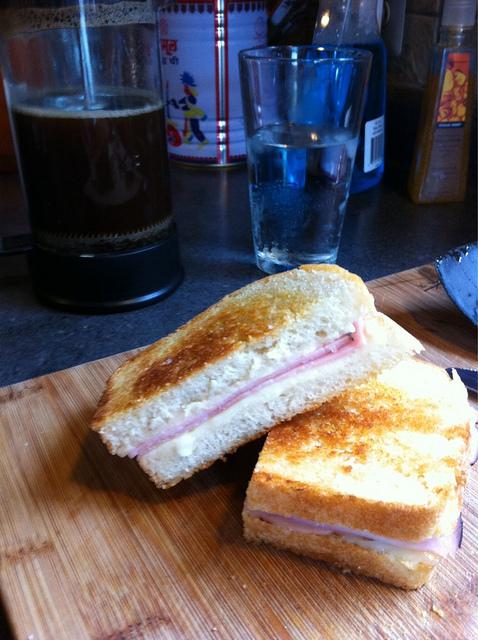What is the name of the container in the background holding coffee? Please explain your reasoning. french press. This has a metal piece inside that presses coffee grounds down to extract coffee 